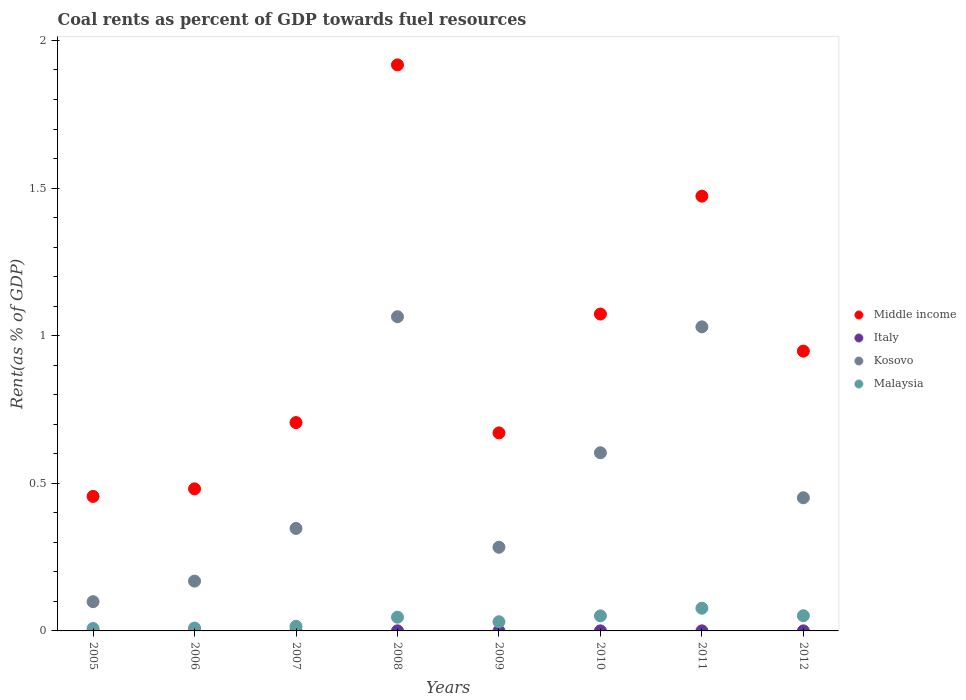What is the coal rent in Malaysia in 2011?
Provide a succinct answer. 0.08. Across all years, what is the maximum coal rent in Middle income?
Your answer should be very brief. 1.92. Across all years, what is the minimum coal rent in Italy?
Your answer should be compact. 5.16849671469394e-6. In which year was the coal rent in Italy maximum?
Provide a short and direct response. 2008. What is the total coal rent in Kosovo in the graph?
Offer a very short reply. 4.05. What is the difference between the coal rent in Italy in 2006 and that in 2010?
Make the answer very short. -0. What is the difference between the coal rent in Kosovo in 2012 and the coal rent in Italy in 2007?
Your answer should be very brief. 0.45. What is the average coal rent in Italy per year?
Offer a terse response. 0. In the year 2011, what is the difference between the coal rent in Italy and coal rent in Malaysia?
Provide a succinct answer. -0.08. In how many years, is the coal rent in Middle income greater than 0.30000000000000004 %?
Provide a short and direct response. 8. What is the ratio of the coal rent in Kosovo in 2009 to that in 2011?
Ensure brevity in your answer.  0.28. What is the difference between the highest and the second highest coal rent in Middle income?
Your answer should be compact. 0.44. What is the difference between the highest and the lowest coal rent in Kosovo?
Give a very brief answer. 0.97. Is the sum of the coal rent in Middle income in 2009 and 2011 greater than the maximum coal rent in Italy across all years?
Provide a succinct answer. Yes. Is it the case that in every year, the sum of the coal rent in Kosovo and coal rent in Middle income  is greater than the sum of coal rent in Italy and coal rent in Malaysia?
Offer a very short reply. Yes. Does the coal rent in Italy monotonically increase over the years?
Offer a terse response. No. Is the coal rent in Italy strictly greater than the coal rent in Middle income over the years?
Ensure brevity in your answer.  No. How many dotlines are there?
Provide a short and direct response. 4. What is the difference between two consecutive major ticks on the Y-axis?
Provide a short and direct response. 0.5. Where does the legend appear in the graph?
Provide a succinct answer. Center right. What is the title of the graph?
Your response must be concise. Coal rents as percent of GDP towards fuel resources. What is the label or title of the X-axis?
Offer a very short reply. Years. What is the label or title of the Y-axis?
Your answer should be very brief. Rent(as % of GDP). What is the Rent(as % of GDP) in Middle income in 2005?
Your answer should be very brief. 0.46. What is the Rent(as % of GDP) of Italy in 2005?
Provide a short and direct response. 1.52938665315344e-5. What is the Rent(as % of GDP) of Kosovo in 2005?
Keep it short and to the point. 0.1. What is the Rent(as % of GDP) of Malaysia in 2005?
Offer a terse response. 0.01. What is the Rent(as % of GDP) of Middle income in 2006?
Offer a very short reply. 0.48. What is the Rent(as % of GDP) in Italy in 2006?
Your response must be concise. 5.16849671469394e-6. What is the Rent(as % of GDP) in Kosovo in 2006?
Your response must be concise. 0.17. What is the Rent(as % of GDP) of Malaysia in 2006?
Make the answer very short. 0.01. What is the Rent(as % of GDP) of Middle income in 2007?
Keep it short and to the point. 0.71. What is the Rent(as % of GDP) of Italy in 2007?
Ensure brevity in your answer.  0. What is the Rent(as % of GDP) in Kosovo in 2007?
Your answer should be compact. 0.35. What is the Rent(as % of GDP) of Malaysia in 2007?
Make the answer very short. 0.02. What is the Rent(as % of GDP) of Middle income in 2008?
Make the answer very short. 1.92. What is the Rent(as % of GDP) of Italy in 2008?
Offer a terse response. 0. What is the Rent(as % of GDP) in Kosovo in 2008?
Offer a very short reply. 1.06. What is the Rent(as % of GDP) of Malaysia in 2008?
Ensure brevity in your answer.  0.05. What is the Rent(as % of GDP) of Middle income in 2009?
Provide a short and direct response. 0.67. What is the Rent(as % of GDP) of Italy in 2009?
Keep it short and to the point. 5.380155600468061e-5. What is the Rent(as % of GDP) of Kosovo in 2009?
Your response must be concise. 0.28. What is the Rent(as % of GDP) of Malaysia in 2009?
Your answer should be compact. 0.03. What is the Rent(as % of GDP) of Middle income in 2010?
Your answer should be compact. 1.07. What is the Rent(as % of GDP) in Italy in 2010?
Ensure brevity in your answer.  0. What is the Rent(as % of GDP) in Kosovo in 2010?
Offer a terse response. 0.6. What is the Rent(as % of GDP) of Malaysia in 2010?
Keep it short and to the point. 0.05. What is the Rent(as % of GDP) in Middle income in 2011?
Your answer should be compact. 1.47. What is the Rent(as % of GDP) in Italy in 2011?
Keep it short and to the point. 0. What is the Rent(as % of GDP) in Kosovo in 2011?
Give a very brief answer. 1.03. What is the Rent(as % of GDP) of Malaysia in 2011?
Give a very brief answer. 0.08. What is the Rent(as % of GDP) in Middle income in 2012?
Offer a very short reply. 0.95. What is the Rent(as % of GDP) of Italy in 2012?
Offer a terse response. 0. What is the Rent(as % of GDP) in Kosovo in 2012?
Provide a short and direct response. 0.45. What is the Rent(as % of GDP) of Malaysia in 2012?
Your answer should be compact. 0.05. Across all years, what is the maximum Rent(as % of GDP) in Middle income?
Provide a short and direct response. 1.92. Across all years, what is the maximum Rent(as % of GDP) of Italy?
Offer a very short reply. 0. Across all years, what is the maximum Rent(as % of GDP) of Kosovo?
Provide a succinct answer. 1.06. Across all years, what is the maximum Rent(as % of GDP) in Malaysia?
Ensure brevity in your answer.  0.08. Across all years, what is the minimum Rent(as % of GDP) of Middle income?
Make the answer very short. 0.46. Across all years, what is the minimum Rent(as % of GDP) in Italy?
Offer a very short reply. 5.16849671469394e-6. Across all years, what is the minimum Rent(as % of GDP) in Kosovo?
Your answer should be compact. 0.1. Across all years, what is the minimum Rent(as % of GDP) in Malaysia?
Your answer should be compact. 0.01. What is the total Rent(as % of GDP) of Middle income in the graph?
Make the answer very short. 7.72. What is the total Rent(as % of GDP) of Italy in the graph?
Keep it short and to the point. 0. What is the total Rent(as % of GDP) of Kosovo in the graph?
Ensure brevity in your answer.  4.05. What is the total Rent(as % of GDP) of Malaysia in the graph?
Offer a terse response. 0.29. What is the difference between the Rent(as % of GDP) of Middle income in 2005 and that in 2006?
Your answer should be compact. -0.03. What is the difference between the Rent(as % of GDP) in Kosovo in 2005 and that in 2006?
Offer a very short reply. -0.07. What is the difference between the Rent(as % of GDP) of Malaysia in 2005 and that in 2006?
Your answer should be very brief. -0. What is the difference between the Rent(as % of GDP) in Middle income in 2005 and that in 2007?
Your answer should be compact. -0.25. What is the difference between the Rent(as % of GDP) in Italy in 2005 and that in 2007?
Your answer should be compact. -0. What is the difference between the Rent(as % of GDP) of Kosovo in 2005 and that in 2007?
Ensure brevity in your answer.  -0.25. What is the difference between the Rent(as % of GDP) of Malaysia in 2005 and that in 2007?
Give a very brief answer. -0.01. What is the difference between the Rent(as % of GDP) in Middle income in 2005 and that in 2008?
Your answer should be very brief. -1.46. What is the difference between the Rent(as % of GDP) in Italy in 2005 and that in 2008?
Make the answer very short. -0. What is the difference between the Rent(as % of GDP) in Kosovo in 2005 and that in 2008?
Provide a short and direct response. -0.97. What is the difference between the Rent(as % of GDP) in Malaysia in 2005 and that in 2008?
Provide a short and direct response. -0.04. What is the difference between the Rent(as % of GDP) in Middle income in 2005 and that in 2009?
Your response must be concise. -0.22. What is the difference between the Rent(as % of GDP) of Italy in 2005 and that in 2009?
Ensure brevity in your answer.  -0. What is the difference between the Rent(as % of GDP) in Kosovo in 2005 and that in 2009?
Offer a very short reply. -0.18. What is the difference between the Rent(as % of GDP) in Malaysia in 2005 and that in 2009?
Offer a very short reply. -0.02. What is the difference between the Rent(as % of GDP) of Middle income in 2005 and that in 2010?
Offer a terse response. -0.62. What is the difference between the Rent(as % of GDP) in Italy in 2005 and that in 2010?
Your answer should be compact. -0. What is the difference between the Rent(as % of GDP) in Kosovo in 2005 and that in 2010?
Your response must be concise. -0.5. What is the difference between the Rent(as % of GDP) of Malaysia in 2005 and that in 2010?
Make the answer very short. -0.04. What is the difference between the Rent(as % of GDP) of Middle income in 2005 and that in 2011?
Your response must be concise. -1.02. What is the difference between the Rent(as % of GDP) in Italy in 2005 and that in 2011?
Keep it short and to the point. -0. What is the difference between the Rent(as % of GDP) in Kosovo in 2005 and that in 2011?
Ensure brevity in your answer.  -0.93. What is the difference between the Rent(as % of GDP) in Malaysia in 2005 and that in 2011?
Your response must be concise. -0.07. What is the difference between the Rent(as % of GDP) of Middle income in 2005 and that in 2012?
Make the answer very short. -0.49. What is the difference between the Rent(as % of GDP) in Italy in 2005 and that in 2012?
Offer a terse response. -0. What is the difference between the Rent(as % of GDP) of Kosovo in 2005 and that in 2012?
Give a very brief answer. -0.35. What is the difference between the Rent(as % of GDP) of Malaysia in 2005 and that in 2012?
Ensure brevity in your answer.  -0.04. What is the difference between the Rent(as % of GDP) of Middle income in 2006 and that in 2007?
Offer a very short reply. -0.22. What is the difference between the Rent(as % of GDP) of Italy in 2006 and that in 2007?
Your answer should be compact. -0. What is the difference between the Rent(as % of GDP) of Kosovo in 2006 and that in 2007?
Offer a very short reply. -0.18. What is the difference between the Rent(as % of GDP) of Malaysia in 2006 and that in 2007?
Provide a succinct answer. -0.01. What is the difference between the Rent(as % of GDP) in Middle income in 2006 and that in 2008?
Your answer should be very brief. -1.44. What is the difference between the Rent(as % of GDP) of Italy in 2006 and that in 2008?
Give a very brief answer. -0. What is the difference between the Rent(as % of GDP) in Kosovo in 2006 and that in 2008?
Offer a terse response. -0.9. What is the difference between the Rent(as % of GDP) of Malaysia in 2006 and that in 2008?
Provide a short and direct response. -0.04. What is the difference between the Rent(as % of GDP) in Middle income in 2006 and that in 2009?
Offer a terse response. -0.19. What is the difference between the Rent(as % of GDP) in Italy in 2006 and that in 2009?
Your answer should be compact. -0. What is the difference between the Rent(as % of GDP) in Kosovo in 2006 and that in 2009?
Your response must be concise. -0.11. What is the difference between the Rent(as % of GDP) in Malaysia in 2006 and that in 2009?
Your answer should be compact. -0.02. What is the difference between the Rent(as % of GDP) in Middle income in 2006 and that in 2010?
Offer a very short reply. -0.59. What is the difference between the Rent(as % of GDP) in Italy in 2006 and that in 2010?
Your answer should be compact. -0. What is the difference between the Rent(as % of GDP) of Kosovo in 2006 and that in 2010?
Your answer should be very brief. -0.43. What is the difference between the Rent(as % of GDP) in Malaysia in 2006 and that in 2010?
Give a very brief answer. -0.04. What is the difference between the Rent(as % of GDP) of Middle income in 2006 and that in 2011?
Provide a short and direct response. -0.99. What is the difference between the Rent(as % of GDP) in Italy in 2006 and that in 2011?
Your answer should be compact. -0. What is the difference between the Rent(as % of GDP) in Kosovo in 2006 and that in 2011?
Offer a terse response. -0.86. What is the difference between the Rent(as % of GDP) of Malaysia in 2006 and that in 2011?
Offer a very short reply. -0.07. What is the difference between the Rent(as % of GDP) in Middle income in 2006 and that in 2012?
Ensure brevity in your answer.  -0.47. What is the difference between the Rent(as % of GDP) in Italy in 2006 and that in 2012?
Offer a very short reply. -0. What is the difference between the Rent(as % of GDP) in Kosovo in 2006 and that in 2012?
Give a very brief answer. -0.28. What is the difference between the Rent(as % of GDP) of Malaysia in 2006 and that in 2012?
Give a very brief answer. -0.04. What is the difference between the Rent(as % of GDP) of Middle income in 2007 and that in 2008?
Provide a short and direct response. -1.21. What is the difference between the Rent(as % of GDP) in Italy in 2007 and that in 2008?
Provide a succinct answer. -0. What is the difference between the Rent(as % of GDP) of Kosovo in 2007 and that in 2008?
Offer a terse response. -0.72. What is the difference between the Rent(as % of GDP) in Malaysia in 2007 and that in 2008?
Your response must be concise. -0.03. What is the difference between the Rent(as % of GDP) in Middle income in 2007 and that in 2009?
Your answer should be compact. 0.04. What is the difference between the Rent(as % of GDP) in Italy in 2007 and that in 2009?
Ensure brevity in your answer.  0. What is the difference between the Rent(as % of GDP) of Kosovo in 2007 and that in 2009?
Your response must be concise. 0.06. What is the difference between the Rent(as % of GDP) in Malaysia in 2007 and that in 2009?
Make the answer very short. -0.02. What is the difference between the Rent(as % of GDP) in Middle income in 2007 and that in 2010?
Your response must be concise. -0.37. What is the difference between the Rent(as % of GDP) of Italy in 2007 and that in 2010?
Your response must be concise. -0. What is the difference between the Rent(as % of GDP) of Kosovo in 2007 and that in 2010?
Your answer should be very brief. -0.26. What is the difference between the Rent(as % of GDP) of Malaysia in 2007 and that in 2010?
Make the answer very short. -0.04. What is the difference between the Rent(as % of GDP) of Middle income in 2007 and that in 2011?
Offer a very short reply. -0.77. What is the difference between the Rent(as % of GDP) of Italy in 2007 and that in 2011?
Provide a short and direct response. -0. What is the difference between the Rent(as % of GDP) of Kosovo in 2007 and that in 2011?
Provide a short and direct response. -0.68. What is the difference between the Rent(as % of GDP) in Malaysia in 2007 and that in 2011?
Ensure brevity in your answer.  -0.06. What is the difference between the Rent(as % of GDP) of Middle income in 2007 and that in 2012?
Your answer should be very brief. -0.24. What is the difference between the Rent(as % of GDP) in Kosovo in 2007 and that in 2012?
Provide a short and direct response. -0.1. What is the difference between the Rent(as % of GDP) in Malaysia in 2007 and that in 2012?
Offer a terse response. -0.04. What is the difference between the Rent(as % of GDP) in Middle income in 2008 and that in 2009?
Make the answer very short. 1.25. What is the difference between the Rent(as % of GDP) of Italy in 2008 and that in 2009?
Make the answer very short. 0. What is the difference between the Rent(as % of GDP) of Kosovo in 2008 and that in 2009?
Provide a short and direct response. 0.78. What is the difference between the Rent(as % of GDP) of Malaysia in 2008 and that in 2009?
Your response must be concise. 0.02. What is the difference between the Rent(as % of GDP) of Middle income in 2008 and that in 2010?
Offer a very short reply. 0.84. What is the difference between the Rent(as % of GDP) of Italy in 2008 and that in 2010?
Keep it short and to the point. 0. What is the difference between the Rent(as % of GDP) in Kosovo in 2008 and that in 2010?
Your answer should be very brief. 0.46. What is the difference between the Rent(as % of GDP) of Malaysia in 2008 and that in 2010?
Provide a short and direct response. -0. What is the difference between the Rent(as % of GDP) in Middle income in 2008 and that in 2011?
Give a very brief answer. 0.44. What is the difference between the Rent(as % of GDP) of Italy in 2008 and that in 2011?
Make the answer very short. 0. What is the difference between the Rent(as % of GDP) in Kosovo in 2008 and that in 2011?
Your response must be concise. 0.03. What is the difference between the Rent(as % of GDP) in Malaysia in 2008 and that in 2011?
Keep it short and to the point. -0.03. What is the difference between the Rent(as % of GDP) of Middle income in 2008 and that in 2012?
Keep it short and to the point. 0.97. What is the difference between the Rent(as % of GDP) of Kosovo in 2008 and that in 2012?
Keep it short and to the point. 0.61. What is the difference between the Rent(as % of GDP) in Malaysia in 2008 and that in 2012?
Your response must be concise. -0.01. What is the difference between the Rent(as % of GDP) in Middle income in 2009 and that in 2010?
Give a very brief answer. -0.4. What is the difference between the Rent(as % of GDP) of Italy in 2009 and that in 2010?
Offer a very short reply. -0. What is the difference between the Rent(as % of GDP) of Kosovo in 2009 and that in 2010?
Provide a succinct answer. -0.32. What is the difference between the Rent(as % of GDP) of Malaysia in 2009 and that in 2010?
Offer a very short reply. -0.02. What is the difference between the Rent(as % of GDP) in Middle income in 2009 and that in 2011?
Give a very brief answer. -0.8. What is the difference between the Rent(as % of GDP) in Italy in 2009 and that in 2011?
Make the answer very short. -0. What is the difference between the Rent(as % of GDP) of Kosovo in 2009 and that in 2011?
Ensure brevity in your answer.  -0.75. What is the difference between the Rent(as % of GDP) of Malaysia in 2009 and that in 2011?
Give a very brief answer. -0.05. What is the difference between the Rent(as % of GDP) of Middle income in 2009 and that in 2012?
Offer a terse response. -0.28. What is the difference between the Rent(as % of GDP) in Italy in 2009 and that in 2012?
Provide a succinct answer. -0. What is the difference between the Rent(as % of GDP) of Kosovo in 2009 and that in 2012?
Offer a terse response. -0.17. What is the difference between the Rent(as % of GDP) in Malaysia in 2009 and that in 2012?
Give a very brief answer. -0.02. What is the difference between the Rent(as % of GDP) in Middle income in 2010 and that in 2011?
Your response must be concise. -0.4. What is the difference between the Rent(as % of GDP) of Italy in 2010 and that in 2011?
Your answer should be compact. -0. What is the difference between the Rent(as % of GDP) of Kosovo in 2010 and that in 2011?
Offer a very short reply. -0.43. What is the difference between the Rent(as % of GDP) in Malaysia in 2010 and that in 2011?
Give a very brief answer. -0.03. What is the difference between the Rent(as % of GDP) in Middle income in 2010 and that in 2012?
Offer a very short reply. 0.13. What is the difference between the Rent(as % of GDP) of Kosovo in 2010 and that in 2012?
Your answer should be compact. 0.15. What is the difference between the Rent(as % of GDP) of Malaysia in 2010 and that in 2012?
Provide a short and direct response. -0. What is the difference between the Rent(as % of GDP) in Middle income in 2011 and that in 2012?
Give a very brief answer. 0.52. What is the difference between the Rent(as % of GDP) in Italy in 2011 and that in 2012?
Provide a succinct answer. 0. What is the difference between the Rent(as % of GDP) of Kosovo in 2011 and that in 2012?
Offer a terse response. 0.58. What is the difference between the Rent(as % of GDP) in Malaysia in 2011 and that in 2012?
Provide a short and direct response. 0.03. What is the difference between the Rent(as % of GDP) of Middle income in 2005 and the Rent(as % of GDP) of Italy in 2006?
Your answer should be very brief. 0.46. What is the difference between the Rent(as % of GDP) of Middle income in 2005 and the Rent(as % of GDP) of Kosovo in 2006?
Provide a short and direct response. 0.29. What is the difference between the Rent(as % of GDP) in Middle income in 2005 and the Rent(as % of GDP) in Malaysia in 2006?
Your response must be concise. 0.45. What is the difference between the Rent(as % of GDP) in Italy in 2005 and the Rent(as % of GDP) in Kosovo in 2006?
Ensure brevity in your answer.  -0.17. What is the difference between the Rent(as % of GDP) in Italy in 2005 and the Rent(as % of GDP) in Malaysia in 2006?
Keep it short and to the point. -0.01. What is the difference between the Rent(as % of GDP) of Kosovo in 2005 and the Rent(as % of GDP) of Malaysia in 2006?
Your answer should be very brief. 0.09. What is the difference between the Rent(as % of GDP) in Middle income in 2005 and the Rent(as % of GDP) in Italy in 2007?
Give a very brief answer. 0.46. What is the difference between the Rent(as % of GDP) in Middle income in 2005 and the Rent(as % of GDP) in Kosovo in 2007?
Offer a terse response. 0.11. What is the difference between the Rent(as % of GDP) in Middle income in 2005 and the Rent(as % of GDP) in Malaysia in 2007?
Provide a succinct answer. 0.44. What is the difference between the Rent(as % of GDP) in Italy in 2005 and the Rent(as % of GDP) in Kosovo in 2007?
Offer a very short reply. -0.35. What is the difference between the Rent(as % of GDP) of Italy in 2005 and the Rent(as % of GDP) of Malaysia in 2007?
Offer a very short reply. -0.02. What is the difference between the Rent(as % of GDP) in Kosovo in 2005 and the Rent(as % of GDP) in Malaysia in 2007?
Provide a succinct answer. 0.08. What is the difference between the Rent(as % of GDP) in Middle income in 2005 and the Rent(as % of GDP) in Italy in 2008?
Offer a terse response. 0.46. What is the difference between the Rent(as % of GDP) in Middle income in 2005 and the Rent(as % of GDP) in Kosovo in 2008?
Your answer should be compact. -0.61. What is the difference between the Rent(as % of GDP) of Middle income in 2005 and the Rent(as % of GDP) of Malaysia in 2008?
Offer a very short reply. 0.41. What is the difference between the Rent(as % of GDP) in Italy in 2005 and the Rent(as % of GDP) in Kosovo in 2008?
Provide a short and direct response. -1.06. What is the difference between the Rent(as % of GDP) of Italy in 2005 and the Rent(as % of GDP) of Malaysia in 2008?
Your response must be concise. -0.05. What is the difference between the Rent(as % of GDP) of Kosovo in 2005 and the Rent(as % of GDP) of Malaysia in 2008?
Provide a short and direct response. 0.05. What is the difference between the Rent(as % of GDP) of Middle income in 2005 and the Rent(as % of GDP) of Italy in 2009?
Offer a terse response. 0.46. What is the difference between the Rent(as % of GDP) of Middle income in 2005 and the Rent(as % of GDP) of Kosovo in 2009?
Ensure brevity in your answer.  0.17. What is the difference between the Rent(as % of GDP) of Middle income in 2005 and the Rent(as % of GDP) of Malaysia in 2009?
Offer a very short reply. 0.42. What is the difference between the Rent(as % of GDP) in Italy in 2005 and the Rent(as % of GDP) in Kosovo in 2009?
Ensure brevity in your answer.  -0.28. What is the difference between the Rent(as % of GDP) in Italy in 2005 and the Rent(as % of GDP) in Malaysia in 2009?
Keep it short and to the point. -0.03. What is the difference between the Rent(as % of GDP) of Kosovo in 2005 and the Rent(as % of GDP) of Malaysia in 2009?
Your answer should be compact. 0.07. What is the difference between the Rent(as % of GDP) in Middle income in 2005 and the Rent(as % of GDP) in Italy in 2010?
Offer a very short reply. 0.46. What is the difference between the Rent(as % of GDP) of Middle income in 2005 and the Rent(as % of GDP) of Kosovo in 2010?
Offer a terse response. -0.15. What is the difference between the Rent(as % of GDP) in Middle income in 2005 and the Rent(as % of GDP) in Malaysia in 2010?
Your response must be concise. 0.4. What is the difference between the Rent(as % of GDP) of Italy in 2005 and the Rent(as % of GDP) of Kosovo in 2010?
Provide a succinct answer. -0.6. What is the difference between the Rent(as % of GDP) in Italy in 2005 and the Rent(as % of GDP) in Malaysia in 2010?
Offer a very short reply. -0.05. What is the difference between the Rent(as % of GDP) in Kosovo in 2005 and the Rent(as % of GDP) in Malaysia in 2010?
Ensure brevity in your answer.  0.05. What is the difference between the Rent(as % of GDP) of Middle income in 2005 and the Rent(as % of GDP) of Italy in 2011?
Provide a succinct answer. 0.46. What is the difference between the Rent(as % of GDP) in Middle income in 2005 and the Rent(as % of GDP) in Kosovo in 2011?
Make the answer very short. -0.57. What is the difference between the Rent(as % of GDP) in Middle income in 2005 and the Rent(as % of GDP) in Malaysia in 2011?
Make the answer very short. 0.38. What is the difference between the Rent(as % of GDP) in Italy in 2005 and the Rent(as % of GDP) in Kosovo in 2011?
Your answer should be compact. -1.03. What is the difference between the Rent(as % of GDP) of Italy in 2005 and the Rent(as % of GDP) of Malaysia in 2011?
Your response must be concise. -0.08. What is the difference between the Rent(as % of GDP) in Kosovo in 2005 and the Rent(as % of GDP) in Malaysia in 2011?
Provide a short and direct response. 0.02. What is the difference between the Rent(as % of GDP) of Middle income in 2005 and the Rent(as % of GDP) of Italy in 2012?
Your answer should be compact. 0.46. What is the difference between the Rent(as % of GDP) in Middle income in 2005 and the Rent(as % of GDP) in Kosovo in 2012?
Provide a succinct answer. 0. What is the difference between the Rent(as % of GDP) in Middle income in 2005 and the Rent(as % of GDP) in Malaysia in 2012?
Your answer should be compact. 0.4. What is the difference between the Rent(as % of GDP) of Italy in 2005 and the Rent(as % of GDP) of Kosovo in 2012?
Your answer should be compact. -0.45. What is the difference between the Rent(as % of GDP) of Italy in 2005 and the Rent(as % of GDP) of Malaysia in 2012?
Offer a very short reply. -0.05. What is the difference between the Rent(as % of GDP) in Kosovo in 2005 and the Rent(as % of GDP) in Malaysia in 2012?
Make the answer very short. 0.05. What is the difference between the Rent(as % of GDP) of Middle income in 2006 and the Rent(as % of GDP) of Italy in 2007?
Give a very brief answer. 0.48. What is the difference between the Rent(as % of GDP) of Middle income in 2006 and the Rent(as % of GDP) of Kosovo in 2007?
Your answer should be compact. 0.13. What is the difference between the Rent(as % of GDP) of Middle income in 2006 and the Rent(as % of GDP) of Malaysia in 2007?
Offer a terse response. 0.47. What is the difference between the Rent(as % of GDP) of Italy in 2006 and the Rent(as % of GDP) of Kosovo in 2007?
Your response must be concise. -0.35. What is the difference between the Rent(as % of GDP) of Italy in 2006 and the Rent(as % of GDP) of Malaysia in 2007?
Make the answer very short. -0.02. What is the difference between the Rent(as % of GDP) of Kosovo in 2006 and the Rent(as % of GDP) of Malaysia in 2007?
Your answer should be very brief. 0.15. What is the difference between the Rent(as % of GDP) of Middle income in 2006 and the Rent(as % of GDP) of Italy in 2008?
Offer a very short reply. 0.48. What is the difference between the Rent(as % of GDP) of Middle income in 2006 and the Rent(as % of GDP) of Kosovo in 2008?
Make the answer very short. -0.58. What is the difference between the Rent(as % of GDP) in Middle income in 2006 and the Rent(as % of GDP) in Malaysia in 2008?
Provide a short and direct response. 0.43. What is the difference between the Rent(as % of GDP) in Italy in 2006 and the Rent(as % of GDP) in Kosovo in 2008?
Give a very brief answer. -1.06. What is the difference between the Rent(as % of GDP) of Italy in 2006 and the Rent(as % of GDP) of Malaysia in 2008?
Your response must be concise. -0.05. What is the difference between the Rent(as % of GDP) of Kosovo in 2006 and the Rent(as % of GDP) of Malaysia in 2008?
Give a very brief answer. 0.12. What is the difference between the Rent(as % of GDP) of Middle income in 2006 and the Rent(as % of GDP) of Italy in 2009?
Your response must be concise. 0.48. What is the difference between the Rent(as % of GDP) in Middle income in 2006 and the Rent(as % of GDP) in Kosovo in 2009?
Your answer should be very brief. 0.2. What is the difference between the Rent(as % of GDP) in Middle income in 2006 and the Rent(as % of GDP) in Malaysia in 2009?
Offer a very short reply. 0.45. What is the difference between the Rent(as % of GDP) of Italy in 2006 and the Rent(as % of GDP) of Kosovo in 2009?
Ensure brevity in your answer.  -0.28. What is the difference between the Rent(as % of GDP) in Italy in 2006 and the Rent(as % of GDP) in Malaysia in 2009?
Keep it short and to the point. -0.03. What is the difference between the Rent(as % of GDP) of Kosovo in 2006 and the Rent(as % of GDP) of Malaysia in 2009?
Give a very brief answer. 0.14. What is the difference between the Rent(as % of GDP) of Middle income in 2006 and the Rent(as % of GDP) of Italy in 2010?
Make the answer very short. 0.48. What is the difference between the Rent(as % of GDP) in Middle income in 2006 and the Rent(as % of GDP) in Kosovo in 2010?
Make the answer very short. -0.12. What is the difference between the Rent(as % of GDP) in Middle income in 2006 and the Rent(as % of GDP) in Malaysia in 2010?
Your response must be concise. 0.43. What is the difference between the Rent(as % of GDP) of Italy in 2006 and the Rent(as % of GDP) of Kosovo in 2010?
Your answer should be compact. -0.6. What is the difference between the Rent(as % of GDP) of Italy in 2006 and the Rent(as % of GDP) of Malaysia in 2010?
Keep it short and to the point. -0.05. What is the difference between the Rent(as % of GDP) in Kosovo in 2006 and the Rent(as % of GDP) in Malaysia in 2010?
Give a very brief answer. 0.12. What is the difference between the Rent(as % of GDP) of Middle income in 2006 and the Rent(as % of GDP) of Italy in 2011?
Ensure brevity in your answer.  0.48. What is the difference between the Rent(as % of GDP) in Middle income in 2006 and the Rent(as % of GDP) in Kosovo in 2011?
Offer a very short reply. -0.55. What is the difference between the Rent(as % of GDP) of Middle income in 2006 and the Rent(as % of GDP) of Malaysia in 2011?
Offer a very short reply. 0.4. What is the difference between the Rent(as % of GDP) in Italy in 2006 and the Rent(as % of GDP) in Kosovo in 2011?
Provide a short and direct response. -1.03. What is the difference between the Rent(as % of GDP) in Italy in 2006 and the Rent(as % of GDP) in Malaysia in 2011?
Ensure brevity in your answer.  -0.08. What is the difference between the Rent(as % of GDP) of Kosovo in 2006 and the Rent(as % of GDP) of Malaysia in 2011?
Give a very brief answer. 0.09. What is the difference between the Rent(as % of GDP) in Middle income in 2006 and the Rent(as % of GDP) in Italy in 2012?
Make the answer very short. 0.48. What is the difference between the Rent(as % of GDP) of Middle income in 2006 and the Rent(as % of GDP) of Kosovo in 2012?
Make the answer very short. 0.03. What is the difference between the Rent(as % of GDP) in Middle income in 2006 and the Rent(as % of GDP) in Malaysia in 2012?
Offer a very short reply. 0.43. What is the difference between the Rent(as % of GDP) in Italy in 2006 and the Rent(as % of GDP) in Kosovo in 2012?
Your answer should be very brief. -0.45. What is the difference between the Rent(as % of GDP) in Italy in 2006 and the Rent(as % of GDP) in Malaysia in 2012?
Your response must be concise. -0.05. What is the difference between the Rent(as % of GDP) of Kosovo in 2006 and the Rent(as % of GDP) of Malaysia in 2012?
Offer a terse response. 0.12. What is the difference between the Rent(as % of GDP) of Middle income in 2007 and the Rent(as % of GDP) of Italy in 2008?
Make the answer very short. 0.71. What is the difference between the Rent(as % of GDP) in Middle income in 2007 and the Rent(as % of GDP) in Kosovo in 2008?
Make the answer very short. -0.36. What is the difference between the Rent(as % of GDP) of Middle income in 2007 and the Rent(as % of GDP) of Malaysia in 2008?
Keep it short and to the point. 0.66. What is the difference between the Rent(as % of GDP) of Italy in 2007 and the Rent(as % of GDP) of Kosovo in 2008?
Your answer should be very brief. -1.06. What is the difference between the Rent(as % of GDP) in Italy in 2007 and the Rent(as % of GDP) in Malaysia in 2008?
Make the answer very short. -0.05. What is the difference between the Rent(as % of GDP) in Kosovo in 2007 and the Rent(as % of GDP) in Malaysia in 2008?
Provide a short and direct response. 0.3. What is the difference between the Rent(as % of GDP) in Middle income in 2007 and the Rent(as % of GDP) in Italy in 2009?
Keep it short and to the point. 0.71. What is the difference between the Rent(as % of GDP) in Middle income in 2007 and the Rent(as % of GDP) in Kosovo in 2009?
Offer a very short reply. 0.42. What is the difference between the Rent(as % of GDP) of Middle income in 2007 and the Rent(as % of GDP) of Malaysia in 2009?
Give a very brief answer. 0.67. What is the difference between the Rent(as % of GDP) in Italy in 2007 and the Rent(as % of GDP) in Kosovo in 2009?
Ensure brevity in your answer.  -0.28. What is the difference between the Rent(as % of GDP) of Italy in 2007 and the Rent(as % of GDP) of Malaysia in 2009?
Your answer should be compact. -0.03. What is the difference between the Rent(as % of GDP) of Kosovo in 2007 and the Rent(as % of GDP) of Malaysia in 2009?
Keep it short and to the point. 0.32. What is the difference between the Rent(as % of GDP) in Middle income in 2007 and the Rent(as % of GDP) in Italy in 2010?
Offer a terse response. 0.71. What is the difference between the Rent(as % of GDP) of Middle income in 2007 and the Rent(as % of GDP) of Kosovo in 2010?
Provide a short and direct response. 0.1. What is the difference between the Rent(as % of GDP) of Middle income in 2007 and the Rent(as % of GDP) of Malaysia in 2010?
Your answer should be compact. 0.65. What is the difference between the Rent(as % of GDP) in Italy in 2007 and the Rent(as % of GDP) in Kosovo in 2010?
Provide a succinct answer. -0.6. What is the difference between the Rent(as % of GDP) in Italy in 2007 and the Rent(as % of GDP) in Malaysia in 2010?
Provide a succinct answer. -0.05. What is the difference between the Rent(as % of GDP) in Kosovo in 2007 and the Rent(as % of GDP) in Malaysia in 2010?
Offer a terse response. 0.3. What is the difference between the Rent(as % of GDP) in Middle income in 2007 and the Rent(as % of GDP) in Italy in 2011?
Give a very brief answer. 0.71. What is the difference between the Rent(as % of GDP) of Middle income in 2007 and the Rent(as % of GDP) of Kosovo in 2011?
Provide a succinct answer. -0.32. What is the difference between the Rent(as % of GDP) of Middle income in 2007 and the Rent(as % of GDP) of Malaysia in 2011?
Keep it short and to the point. 0.63. What is the difference between the Rent(as % of GDP) of Italy in 2007 and the Rent(as % of GDP) of Kosovo in 2011?
Your answer should be compact. -1.03. What is the difference between the Rent(as % of GDP) in Italy in 2007 and the Rent(as % of GDP) in Malaysia in 2011?
Your response must be concise. -0.08. What is the difference between the Rent(as % of GDP) in Kosovo in 2007 and the Rent(as % of GDP) in Malaysia in 2011?
Provide a short and direct response. 0.27. What is the difference between the Rent(as % of GDP) in Middle income in 2007 and the Rent(as % of GDP) in Italy in 2012?
Provide a succinct answer. 0.71. What is the difference between the Rent(as % of GDP) in Middle income in 2007 and the Rent(as % of GDP) in Kosovo in 2012?
Offer a terse response. 0.25. What is the difference between the Rent(as % of GDP) in Middle income in 2007 and the Rent(as % of GDP) in Malaysia in 2012?
Offer a terse response. 0.65. What is the difference between the Rent(as % of GDP) in Italy in 2007 and the Rent(as % of GDP) in Kosovo in 2012?
Provide a short and direct response. -0.45. What is the difference between the Rent(as % of GDP) of Italy in 2007 and the Rent(as % of GDP) of Malaysia in 2012?
Your answer should be compact. -0.05. What is the difference between the Rent(as % of GDP) of Kosovo in 2007 and the Rent(as % of GDP) of Malaysia in 2012?
Make the answer very short. 0.3. What is the difference between the Rent(as % of GDP) in Middle income in 2008 and the Rent(as % of GDP) in Italy in 2009?
Offer a terse response. 1.92. What is the difference between the Rent(as % of GDP) in Middle income in 2008 and the Rent(as % of GDP) in Kosovo in 2009?
Make the answer very short. 1.63. What is the difference between the Rent(as % of GDP) of Middle income in 2008 and the Rent(as % of GDP) of Malaysia in 2009?
Offer a very short reply. 1.89. What is the difference between the Rent(as % of GDP) of Italy in 2008 and the Rent(as % of GDP) of Kosovo in 2009?
Make the answer very short. -0.28. What is the difference between the Rent(as % of GDP) in Italy in 2008 and the Rent(as % of GDP) in Malaysia in 2009?
Provide a succinct answer. -0.03. What is the difference between the Rent(as % of GDP) of Kosovo in 2008 and the Rent(as % of GDP) of Malaysia in 2009?
Provide a short and direct response. 1.03. What is the difference between the Rent(as % of GDP) of Middle income in 2008 and the Rent(as % of GDP) of Italy in 2010?
Give a very brief answer. 1.92. What is the difference between the Rent(as % of GDP) in Middle income in 2008 and the Rent(as % of GDP) in Kosovo in 2010?
Keep it short and to the point. 1.31. What is the difference between the Rent(as % of GDP) in Middle income in 2008 and the Rent(as % of GDP) in Malaysia in 2010?
Offer a very short reply. 1.87. What is the difference between the Rent(as % of GDP) in Italy in 2008 and the Rent(as % of GDP) in Kosovo in 2010?
Keep it short and to the point. -0.6. What is the difference between the Rent(as % of GDP) of Italy in 2008 and the Rent(as % of GDP) of Malaysia in 2010?
Provide a short and direct response. -0.05. What is the difference between the Rent(as % of GDP) of Kosovo in 2008 and the Rent(as % of GDP) of Malaysia in 2010?
Provide a short and direct response. 1.01. What is the difference between the Rent(as % of GDP) in Middle income in 2008 and the Rent(as % of GDP) in Italy in 2011?
Your response must be concise. 1.92. What is the difference between the Rent(as % of GDP) in Middle income in 2008 and the Rent(as % of GDP) in Kosovo in 2011?
Provide a short and direct response. 0.89. What is the difference between the Rent(as % of GDP) of Middle income in 2008 and the Rent(as % of GDP) of Malaysia in 2011?
Provide a short and direct response. 1.84. What is the difference between the Rent(as % of GDP) in Italy in 2008 and the Rent(as % of GDP) in Kosovo in 2011?
Your response must be concise. -1.03. What is the difference between the Rent(as % of GDP) of Italy in 2008 and the Rent(as % of GDP) of Malaysia in 2011?
Give a very brief answer. -0.08. What is the difference between the Rent(as % of GDP) of Kosovo in 2008 and the Rent(as % of GDP) of Malaysia in 2011?
Give a very brief answer. 0.99. What is the difference between the Rent(as % of GDP) in Middle income in 2008 and the Rent(as % of GDP) in Italy in 2012?
Provide a short and direct response. 1.92. What is the difference between the Rent(as % of GDP) in Middle income in 2008 and the Rent(as % of GDP) in Kosovo in 2012?
Make the answer very short. 1.47. What is the difference between the Rent(as % of GDP) of Middle income in 2008 and the Rent(as % of GDP) of Malaysia in 2012?
Your response must be concise. 1.87. What is the difference between the Rent(as % of GDP) of Italy in 2008 and the Rent(as % of GDP) of Kosovo in 2012?
Give a very brief answer. -0.45. What is the difference between the Rent(as % of GDP) in Italy in 2008 and the Rent(as % of GDP) in Malaysia in 2012?
Give a very brief answer. -0.05. What is the difference between the Rent(as % of GDP) in Kosovo in 2008 and the Rent(as % of GDP) in Malaysia in 2012?
Provide a succinct answer. 1.01. What is the difference between the Rent(as % of GDP) in Middle income in 2009 and the Rent(as % of GDP) in Italy in 2010?
Provide a succinct answer. 0.67. What is the difference between the Rent(as % of GDP) of Middle income in 2009 and the Rent(as % of GDP) of Kosovo in 2010?
Give a very brief answer. 0.07. What is the difference between the Rent(as % of GDP) of Middle income in 2009 and the Rent(as % of GDP) of Malaysia in 2010?
Your response must be concise. 0.62. What is the difference between the Rent(as % of GDP) in Italy in 2009 and the Rent(as % of GDP) in Kosovo in 2010?
Make the answer very short. -0.6. What is the difference between the Rent(as % of GDP) in Italy in 2009 and the Rent(as % of GDP) in Malaysia in 2010?
Offer a very short reply. -0.05. What is the difference between the Rent(as % of GDP) in Kosovo in 2009 and the Rent(as % of GDP) in Malaysia in 2010?
Your answer should be compact. 0.23. What is the difference between the Rent(as % of GDP) of Middle income in 2009 and the Rent(as % of GDP) of Italy in 2011?
Ensure brevity in your answer.  0.67. What is the difference between the Rent(as % of GDP) of Middle income in 2009 and the Rent(as % of GDP) of Kosovo in 2011?
Offer a very short reply. -0.36. What is the difference between the Rent(as % of GDP) of Middle income in 2009 and the Rent(as % of GDP) of Malaysia in 2011?
Your answer should be compact. 0.59. What is the difference between the Rent(as % of GDP) of Italy in 2009 and the Rent(as % of GDP) of Kosovo in 2011?
Provide a succinct answer. -1.03. What is the difference between the Rent(as % of GDP) of Italy in 2009 and the Rent(as % of GDP) of Malaysia in 2011?
Your answer should be very brief. -0.08. What is the difference between the Rent(as % of GDP) of Kosovo in 2009 and the Rent(as % of GDP) of Malaysia in 2011?
Ensure brevity in your answer.  0.21. What is the difference between the Rent(as % of GDP) of Middle income in 2009 and the Rent(as % of GDP) of Italy in 2012?
Your response must be concise. 0.67. What is the difference between the Rent(as % of GDP) in Middle income in 2009 and the Rent(as % of GDP) in Kosovo in 2012?
Your answer should be compact. 0.22. What is the difference between the Rent(as % of GDP) of Middle income in 2009 and the Rent(as % of GDP) of Malaysia in 2012?
Offer a very short reply. 0.62. What is the difference between the Rent(as % of GDP) of Italy in 2009 and the Rent(as % of GDP) of Kosovo in 2012?
Make the answer very short. -0.45. What is the difference between the Rent(as % of GDP) in Italy in 2009 and the Rent(as % of GDP) in Malaysia in 2012?
Make the answer very short. -0.05. What is the difference between the Rent(as % of GDP) of Kosovo in 2009 and the Rent(as % of GDP) of Malaysia in 2012?
Your answer should be very brief. 0.23. What is the difference between the Rent(as % of GDP) in Middle income in 2010 and the Rent(as % of GDP) in Italy in 2011?
Your answer should be compact. 1.07. What is the difference between the Rent(as % of GDP) of Middle income in 2010 and the Rent(as % of GDP) of Kosovo in 2011?
Provide a succinct answer. 0.04. What is the difference between the Rent(as % of GDP) of Italy in 2010 and the Rent(as % of GDP) of Kosovo in 2011?
Your response must be concise. -1.03. What is the difference between the Rent(as % of GDP) of Italy in 2010 and the Rent(as % of GDP) of Malaysia in 2011?
Keep it short and to the point. -0.08. What is the difference between the Rent(as % of GDP) of Kosovo in 2010 and the Rent(as % of GDP) of Malaysia in 2011?
Ensure brevity in your answer.  0.53. What is the difference between the Rent(as % of GDP) in Middle income in 2010 and the Rent(as % of GDP) in Italy in 2012?
Your answer should be very brief. 1.07. What is the difference between the Rent(as % of GDP) in Middle income in 2010 and the Rent(as % of GDP) in Kosovo in 2012?
Ensure brevity in your answer.  0.62. What is the difference between the Rent(as % of GDP) in Middle income in 2010 and the Rent(as % of GDP) in Malaysia in 2012?
Keep it short and to the point. 1.02. What is the difference between the Rent(as % of GDP) in Italy in 2010 and the Rent(as % of GDP) in Kosovo in 2012?
Your answer should be compact. -0.45. What is the difference between the Rent(as % of GDP) of Italy in 2010 and the Rent(as % of GDP) of Malaysia in 2012?
Your response must be concise. -0.05. What is the difference between the Rent(as % of GDP) of Kosovo in 2010 and the Rent(as % of GDP) of Malaysia in 2012?
Give a very brief answer. 0.55. What is the difference between the Rent(as % of GDP) in Middle income in 2011 and the Rent(as % of GDP) in Italy in 2012?
Make the answer very short. 1.47. What is the difference between the Rent(as % of GDP) in Middle income in 2011 and the Rent(as % of GDP) in Kosovo in 2012?
Offer a very short reply. 1.02. What is the difference between the Rent(as % of GDP) of Middle income in 2011 and the Rent(as % of GDP) of Malaysia in 2012?
Make the answer very short. 1.42. What is the difference between the Rent(as % of GDP) in Italy in 2011 and the Rent(as % of GDP) in Kosovo in 2012?
Offer a terse response. -0.45. What is the difference between the Rent(as % of GDP) in Italy in 2011 and the Rent(as % of GDP) in Malaysia in 2012?
Your answer should be compact. -0.05. What is the difference between the Rent(as % of GDP) of Kosovo in 2011 and the Rent(as % of GDP) of Malaysia in 2012?
Your answer should be very brief. 0.98. What is the average Rent(as % of GDP) in Middle income per year?
Your answer should be compact. 0.97. What is the average Rent(as % of GDP) in Italy per year?
Offer a very short reply. 0. What is the average Rent(as % of GDP) of Kosovo per year?
Provide a short and direct response. 0.51. What is the average Rent(as % of GDP) in Malaysia per year?
Keep it short and to the point. 0.04. In the year 2005, what is the difference between the Rent(as % of GDP) of Middle income and Rent(as % of GDP) of Italy?
Your answer should be compact. 0.46. In the year 2005, what is the difference between the Rent(as % of GDP) in Middle income and Rent(as % of GDP) in Kosovo?
Your response must be concise. 0.36. In the year 2005, what is the difference between the Rent(as % of GDP) of Middle income and Rent(as % of GDP) of Malaysia?
Your response must be concise. 0.45. In the year 2005, what is the difference between the Rent(as % of GDP) of Italy and Rent(as % of GDP) of Kosovo?
Make the answer very short. -0.1. In the year 2005, what is the difference between the Rent(as % of GDP) of Italy and Rent(as % of GDP) of Malaysia?
Make the answer very short. -0.01. In the year 2005, what is the difference between the Rent(as % of GDP) in Kosovo and Rent(as % of GDP) in Malaysia?
Provide a succinct answer. 0.09. In the year 2006, what is the difference between the Rent(as % of GDP) of Middle income and Rent(as % of GDP) of Italy?
Your answer should be compact. 0.48. In the year 2006, what is the difference between the Rent(as % of GDP) of Middle income and Rent(as % of GDP) of Kosovo?
Keep it short and to the point. 0.31. In the year 2006, what is the difference between the Rent(as % of GDP) of Middle income and Rent(as % of GDP) of Malaysia?
Provide a short and direct response. 0.47. In the year 2006, what is the difference between the Rent(as % of GDP) of Italy and Rent(as % of GDP) of Kosovo?
Give a very brief answer. -0.17. In the year 2006, what is the difference between the Rent(as % of GDP) of Italy and Rent(as % of GDP) of Malaysia?
Your answer should be compact. -0.01. In the year 2006, what is the difference between the Rent(as % of GDP) of Kosovo and Rent(as % of GDP) of Malaysia?
Make the answer very short. 0.16. In the year 2007, what is the difference between the Rent(as % of GDP) in Middle income and Rent(as % of GDP) in Italy?
Offer a terse response. 0.71. In the year 2007, what is the difference between the Rent(as % of GDP) of Middle income and Rent(as % of GDP) of Kosovo?
Give a very brief answer. 0.36. In the year 2007, what is the difference between the Rent(as % of GDP) in Middle income and Rent(as % of GDP) in Malaysia?
Offer a terse response. 0.69. In the year 2007, what is the difference between the Rent(as % of GDP) in Italy and Rent(as % of GDP) in Kosovo?
Ensure brevity in your answer.  -0.35. In the year 2007, what is the difference between the Rent(as % of GDP) in Italy and Rent(as % of GDP) in Malaysia?
Offer a very short reply. -0.02. In the year 2007, what is the difference between the Rent(as % of GDP) in Kosovo and Rent(as % of GDP) in Malaysia?
Provide a succinct answer. 0.33. In the year 2008, what is the difference between the Rent(as % of GDP) in Middle income and Rent(as % of GDP) in Italy?
Give a very brief answer. 1.92. In the year 2008, what is the difference between the Rent(as % of GDP) of Middle income and Rent(as % of GDP) of Kosovo?
Offer a very short reply. 0.85. In the year 2008, what is the difference between the Rent(as % of GDP) in Middle income and Rent(as % of GDP) in Malaysia?
Give a very brief answer. 1.87. In the year 2008, what is the difference between the Rent(as % of GDP) of Italy and Rent(as % of GDP) of Kosovo?
Ensure brevity in your answer.  -1.06. In the year 2008, what is the difference between the Rent(as % of GDP) of Italy and Rent(as % of GDP) of Malaysia?
Give a very brief answer. -0.05. In the year 2008, what is the difference between the Rent(as % of GDP) of Kosovo and Rent(as % of GDP) of Malaysia?
Offer a very short reply. 1.02. In the year 2009, what is the difference between the Rent(as % of GDP) in Middle income and Rent(as % of GDP) in Italy?
Offer a terse response. 0.67. In the year 2009, what is the difference between the Rent(as % of GDP) in Middle income and Rent(as % of GDP) in Kosovo?
Provide a short and direct response. 0.39. In the year 2009, what is the difference between the Rent(as % of GDP) of Middle income and Rent(as % of GDP) of Malaysia?
Your response must be concise. 0.64. In the year 2009, what is the difference between the Rent(as % of GDP) in Italy and Rent(as % of GDP) in Kosovo?
Offer a very short reply. -0.28. In the year 2009, what is the difference between the Rent(as % of GDP) in Italy and Rent(as % of GDP) in Malaysia?
Keep it short and to the point. -0.03. In the year 2009, what is the difference between the Rent(as % of GDP) of Kosovo and Rent(as % of GDP) of Malaysia?
Offer a very short reply. 0.25. In the year 2010, what is the difference between the Rent(as % of GDP) in Middle income and Rent(as % of GDP) in Italy?
Your response must be concise. 1.07. In the year 2010, what is the difference between the Rent(as % of GDP) in Middle income and Rent(as % of GDP) in Kosovo?
Your answer should be very brief. 0.47. In the year 2010, what is the difference between the Rent(as % of GDP) in Middle income and Rent(as % of GDP) in Malaysia?
Offer a very short reply. 1.02. In the year 2010, what is the difference between the Rent(as % of GDP) of Italy and Rent(as % of GDP) of Kosovo?
Provide a succinct answer. -0.6. In the year 2010, what is the difference between the Rent(as % of GDP) in Italy and Rent(as % of GDP) in Malaysia?
Provide a succinct answer. -0.05. In the year 2010, what is the difference between the Rent(as % of GDP) in Kosovo and Rent(as % of GDP) in Malaysia?
Your answer should be very brief. 0.55. In the year 2011, what is the difference between the Rent(as % of GDP) in Middle income and Rent(as % of GDP) in Italy?
Provide a short and direct response. 1.47. In the year 2011, what is the difference between the Rent(as % of GDP) of Middle income and Rent(as % of GDP) of Kosovo?
Your answer should be very brief. 0.44. In the year 2011, what is the difference between the Rent(as % of GDP) of Middle income and Rent(as % of GDP) of Malaysia?
Offer a very short reply. 1.4. In the year 2011, what is the difference between the Rent(as % of GDP) in Italy and Rent(as % of GDP) in Kosovo?
Ensure brevity in your answer.  -1.03. In the year 2011, what is the difference between the Rent(as % of GDP) of Italy and Rent(as % of GDP) of Malaysia?
Keep it short and to the point. -0.08. In the year 2011, what is the difference between the Rent(as % of GDP) of Kosovo and Rent(as % of GDP) of Malaysia?
Provide a succinct answer. 0.95. In the year 2012, what is the difference between the Rent(as % of GDP) of Middle income and Rent(as % of GDP) of Italy?
Provide a short and direct response. 0.95. In the year 2012, what is the difference between the Rent(as % of GDP) of Middle income and Rent(as % of GDP) of Kosovo?
Offer a very short reply. 0.5. In the year 2012, what is the difference between the Rent(as % of GDP) in Middle income and Rent(as % of GDP) in Malaysia?
Provide a short and direct response. 0.9. In the year 2012, what is the difference between the Rent(as % of GDP) of Italy and Rent(as % of GDP) of Kosovo?
Offer a terse response. -0.45. In the year 2012, what is the difference between the Rent(as % of GDP) in Italy and Rent(as % of GDP) in Malaysia?
Make the answer very short. -0.05. In the year 2012, what is the difference between the Rent(as % of GDP) of Kosovo and Rent(as % of GDP) of Malaysia?
Provide a short and direct response. 0.4. What is the ratio of the Rent(as % of GDP) of Middle income in 2005 to that in 2006?
Provide a succinct answer. 0.95. What is the ratio of the Rent(as % of GDP) of Italy in 2005 to that in 2006?
Offer a terse response. 2.96. What is the ratio of the Rent(as % of GDP) in Kosovo in 2005 to that in 2006?
Your answer should be compact. 0.59. What is the ratio of the Rent(as % of GDP) in Malaysia in 2005 to that in 2006?
Provide a succinct answer. 0.85. What is the ratio of the Rent(as % of GDP) of Middle income in 2005 to that in 2007?
Keep it short and to the point. 0.65. What is the ratio of the Rent(as % of GDP) of Italy in 2005 to that in 2007?
Offer a terse response. 0.14. What is the ratio of the Rent(as % of GDP) of Kosovo in 2005 to that in 2007?
Your answer should be very brief. 0.29. What is the ratio of the Rent(as % of GDP) in Malaysia in 2005 to that in 2007?
Make the answer very short. 0.53. What is the ratio of the Rent(as % of GDP) of Middle income in 2005 to that in 2008?
Offer a very short reply. 0.24. What is the ratio of the Rent(as % of GDP) of Italy in 2005 to that in 2008?
Your response must be concise. 0.04. What is the ratio of the Rent(as % of GDP) of Kosovo in 2005 to that in 2008?
Give a very brief answer. 0.09. What is the ratio of the Rent(as % of GDP) in Malaysia in 2005 to that in 2008?
Provide a succinct answer. 0.18. What is the ratio of the Rent(as % of GDP) of Middle income in 2005 to that in 2009?
Ensure brevity in your answer.  0.68. What is the ratio of the Rent(as % of GDP) in Italy in 2005 to that in 2009?
Your answer should be compact. 0.28. What is the ratio of the Rent(as % of GDP) in Kosovo in 2005 to that in 2009?
Ensure brevity in your answer.  0.35. What is the ratio of the Rent(as % of GDP) in Malaysia in 2005 to that in 2009?
Your answer should be very brief. 0.26. What is the ratio of the Rent(as % of GDP) in Middle income in 2005 to that in 2010?
Offer a terse response. 0.42. What is the ratio of the Rent(as % of GDP) in Italy in 2005 to that in 2010?
Keep it short and to the point. 0.08. What is the ratio of the Rent(as % of GDP) in Kosovo in 2005 to that in 2010?
Your answer should be very brief. 0.16. What is the ratio of the Rent(as % of GDP) of Malaysia in 2005 to that in 2010?
Offer a terse response. 0.16. What is the ratio of the Rent(as % of GDP) in Middle income in 2005 to that in 2011?
Keep it short and to the point. 0.31. What is the ratio of the Rent(as % of GDP) of Italy in 2005 to that in 2011?
Offer a very short reply. 0.06. What is the ratio of the Rent(as % of GDP) of Kosovo in 2005 to that in 2011?
Make the answer very short. 0.1. What is the ratio of the Rent(as % of GDP) in Malaysia in 2005 to that in 2011?
Your response must be concise. 0.11. What is the ratio of the Rent(as % of GDP) in Middle income in 2005 to that in 2012?
Provide a short and direct response. 0.48. What is the ratio of the Rent(as % of GDP) in Italy in 2005 to that in 2012?
Your answer should be very brief. 0.11. What is the ratio of the Rent(as % of GDP) of Kosovo in 2005 to that in 2012?
Provide a short and direct response. 0.22. What is the ratio of the Rent(as % of GDP) in Malaysia in 2005 to that in 2012?
Provide a succinct answer. 0.16. What is the ratio of the Rent(as % of GDP) in Middle income in 2006 to that in 2007?
Your answer should be compact. 0.68. What is the ratio of the Rent(as % of GDP) in Italy in 2006 to that in 2007?
Offer a very short reply. 0.05. What is the ratio of the Rent(as % of GDP) of Kosovo in 2006 to that in 2007?
Make the answer very short. 0.49. What is the ratio of the Rent(as % of GDP) in Malaysia in 2006 to that in 2007?
Your answer should be very brief. 0.62. What is the ratio of the Rent(as % of GDP) in Middle income in 2006 to that in 2008?
Make the answer very short. 0.25. What is the ratio of the Rent(as % of GDP) of Italy in 2006 to that in 2008?
Offer a terse response. 0.01. What is the ratio of the Rent(as % of GDP) in Kosovo in 2006 to that in 2008?
Your response must be concise. 0.16. What is the ratio of the Rent(as % of GDP) in Malaysia in 2006 to that in 2008?
Your response must be concise. 0.21. What is the ratio of the Rent(as % of GDP) in Middle income in 2006 to that in 2009?
Your answer should be very brief. 0.72. What is the ratio of the Rent(as % of GDP) of Italy in 2006 to that in 2009?
Your response must be concise. 0.1. What is the ratio of the Rent(as % of GDP) of Kosovo in 2006 to that in 2009?
Provide a succinct answer. 0.6. What is the ratio of the Rent(as % of GDP) in Malaysia in 2006 to that in 2009?
Offer a terse response. 0.31. What is the ratio of the Rent(as % of GDP) in Middle income in 2006 to that in 2010?
Offer a terse response. 0.45. What is the ratio of the Rent(as % of GDP) in Italy in 2006 to that in 2010?
Offer a very short reply. 0.03. What is the ratio of the Rent(as % of GDP) in Kosovo in 2006 to that in 2010?
Give a very brief answer. 0.28. What is the ratio of the Rent(as % of GDP) in Malaysia in 2006 to that in 2010?
Your answer should be very brief. 0.19. What is the ratio of the Rent(as % of GDP) in Middle income in 2006 to that in 2011?
Provide a succinct answer. 0.33. What is the ratio of the Rent(as % of GDP) in Italy in 2006 to that in 2011?
Offer a very short reply. 0.02. What is the ratio of the Rent(as % of GDP) of Kosovo in 2006 to that in 2011?
Make the answer very short. 0.16. What is the ratio of the Rent(as % of GDP) in Malaysia in 2006 to that in 2011?
Provide a short and direct response. 0.13. What is the ratio of the Rent(as % of GDP) in Middle income in 2006 to that in 2012?
Make the answer very short. 0.51. What is the ratio of the Rent(as % of GDP) of Italy in 2006 to that in 2012?
Offer a very short reply. 0.04. What is the ratio of the Rent(as % of GDP) in Kosovo in 2006 to that in 2012?
Give a very brief answer. 0.37. What is the ratio of the Rent(as % of GDP) in Malaysia in 2006 to that in 2012?
Give a very brief answer. 0.19. What is the ratio of the Rent(as % of GDP) of Middle income in 2007 to that in 2008?
Provide a short and direct response. 0.37. What is the ratio of the Rent(as % of GDP) of Italy in 2007 to that in 2008?
Your answer should be very brief. 0.32. What is the ratio of the Rent(as % of GDP) in Kosovo in 2007 to that in 2008?
Provide a succinct answer. 0.33. What is the ratio of the Rent(as % of GDP) in Malaysia in 2007 to that in 2008?
Your answer should be very brief. 0.33. What is the ratio of the Rent(as % of GDP) in Middle income in 2007 to that in 2009?
Provide a short and direct response. 1.05. What is the ratio of the Rent(as % of GDP) in Italy in 2007 to that in 2009?
Provide a succinct answer. 2.07. What is the ratio of the Rent(as % of GDP) of Kosovo in 2007 to that in 2009?
Give a very brief answer. 1.23. What is the ratio of the Rent(as % of GDP) in Malaysia in 2007 to that in 2009?
Make the answer very short. 0.5. What is the ratio of the Rent(as % of GDP) in Middle income in 2007 to that in 2010?
Offer a very short reply. 0.66. What is the ratio of the Rent(as % of GDP) in Italy in 2007 to that in 2010?
Make the answer very short. 0.6. What is the ratio of the Rent(as % of GDP) of Kosovo in 2007 to that in 2010?
Offer a very short reply. 0.58. What is the ratio of the Rent(as % of GDP) in Malaysia in 2007 to that in 2010?
Your response must be concise. 0.3. What is the ratio of the Rent(as % of GDP) in Middle income in 2007 to that in 2011?
Your answer should be very brief. 0.48. What is the ratio of the Rent(as % of GDP) in Italy in 2007 to that in 2011?
Your answer should be very brief. 0.45. What is the ratio of the Rent(as % of GDP) of Kosovo in 2007 to that in 2011?
Offer a very short reply. 0.34. What is the ratio of the Rent(as % of GDP) of Malaysia in 2007 to that in 2011?
Provide a short and direct response. 0.2. What is the ratio of the Rent(as % of GDP) of Middle income in 2007 to that in 2012?
Provide a short and direct response. 0.74. What is the ratio of the Rent(as % of GDP) of Italy in 2007 to that in 2012?
Provide a short and direct response. 0.78. What is the ratio of the Rent(as % of GDP) in Kosovo in 2007 to that in 2012?
Offer a very short reply. 0.77. What is the ratio of the Rent(as % of GDP) of Malaysia in 2007 to that in 2012?
Ensure brevity in your answer.  0.3. What is the ratio of the Rent(as % of GDP) in Middle income in 2008 to that in 2009?
Give a very brief answer. 2.86. What is the ratio of the Rent(as % of GDP) in Italy in 2008 to that in 2009?
Your answer should be compact. 6.54. What is the ratio of the Rent(as % of GDP) in Kosovo in 2008 to that in 2009?
Your answer should be compact. 3.75. What is the ratio of the Rent(as % of GDP) of Malaysia in 2008 to that in 2009?
Your answer should be compact. 1.49. What is the ratio of the Rent(as % of GDP) in Middle income in 2008 to that in 2010?
Ensure brevity in your answer.  1.79. What is the ratio of the Rent(as % of GDP) of Italy in 2008 to that in 2010?
Provide a succinct answer. 1.89. What is the ratio of the Rent(as % of GDP) in Kosovo in 2008 to that in 2010?
Provide a short and direct response. 1.76. What is the ratio of the Rent(as % of GDP) of Malaysia in 2008 to that in 2010?
Provide a short and direct response. 0.91. What is the ratio of the Rent(as % of GDP) of Middle income in 2008 to that in 2011?
Give a very brief answer. 1.3. What is the ratio of the Rent(as % of GDP) of Italy in 2008 to that in 2011?
Offer a terse response. 1.41. What is the ratio of the Rent(as % of GDP) in Malaysia in 2008 to that in 2011?
Ensure brevity in your answer.  0.6. What is the ratio of the Rent(as % of GDP) in Middle income in 2008 to that in 2012?
Make the answer very short. 2.02. What is the ratio of the Rent(as % of GDP) in Italy in 2008 to that in 2012?
Ensure brevity in your answer.  2.48. What is the ratio of the Rent(as % of GDP) of Kosovo in 2008 to that in 2012?
Keep it short and to the point. 2.36. What is the ratio of the Rent(as % of GDP) in Malaysia in 2008 to that in 2012?
Keep it short and to the point. 0.9. What is the ratio of the Rent(as % of GDP) in Middle income in 2009 to that in 2010?
Give a very brief answer. 0.62. What is the ratio of the Rent(as % of GDP) in Italy in 2009 to that in 2010?
Offer a very short reply. 0.29. What is the ratio of the Rent(as % of GDP) in Kosovo in 2009 to that in 2010?
Keep it short and to the point. 0.47. What is the ratio of the Rent(as % of GDP) of Malaysia in 2009 to that in 2010?
Your answer should be compact. 0.61. What is the ratio of the Rent(as % of GDP) in Middle income in 2009 to that in 2011?
Offer a terse response. 0.46. What is the ratio of the Rent(as % of GDP) in Italy in 2009 to that in 2011?
Your response must be concise. 0.22. What is the ratio of the Rent(as % of GDP) in Kosovo in 2009 to that in 2011?
Your answer should be compact. 0.28. What is the ratio of the Rent(as % of GDP) in Malaysia in 2009 to that in 2011?
Provide a short and direct response. 0.4. What is the ratio of the Rent(as % of GDP) in Middle income in 2009 to that in 2012?
Make the answer very short. 0.71. What is the ratio of the Rent(as % of GDP) in Italy in 2009 to that in 2012?
Offer a very short reply. 0.38. What is the ratio of the Rent(as % of GDP) of Kosovo in 2009 to that in 2012?
Provide a short and direct response. 0.63. What is the ratio of the Rent(as % of GDP) of Malaysia in 2009 to that in 2012?
Provide a short and direct response. 0.6. What is the ratio of the Rent(as % of GDP) of Middle income in 2010 to that in 2011?
Provide a short and direct response. 0.73. What is the ratio of the Rent(as % of GDP) of Italy in 2010 to that in 2011?
Your response must be concise. 0.75. What is the ratio of the Rent(as % of GDP) in Kosovo in 2010 to that in 2011?
Your response must be concise. 0.59. What is the ratio of the Rent(as % of GDP) in Malaysia in 2010 to that in 2011?
Offer a terse response. 0.66. What is the ratio of the Rent(as % of GDP) of Middle income in 2010 to that in 2012?
Keep it short and to the point. 1.13. What is the ratio of the Rent(as % of GDP) in Italy in 2010 to that in 2012?
Provide a short and direct response. 1.31. What is the ratio of the Rent(as % of GDP) in Kosovo in 2010 to that in 2012?
Your answer should be compact. 1.34. What is the ratio of the Rent(as % of GDP) in Middle income in 2011 to that in 2012?
Provide a short and direct response. 1.55. What is the ratio of the Rent(as % of GDP) in Italy in 2011 to that in 2012?
Provide a succinct answer. 1.76. What is the ratio of the Rent(as % of GDP) in Kosovo in 2011 to that in 2012?
Offer a very short reply. 2.28. What is the ratio of the Rent(as % of GDP) in Malaysia in 2011 to that in 2012?
Make the answer very short. 1.49. What is the difference between the highest and the second highest Rent(as % of GDP) in Middle income?
Provide a short and direct response. 0.44. What is the difference between the highest and the second highest Rent(as % of GDP) in Kosovo?
Offer a very short reply. 0.03. What is the difference between the highest and the second highest Rent(as % of GDP) in Malaysia?
Keep it short and to the point. 0.03. What is the difference between the highest and the lowest Rent(as % of GDP) in Middle income?
Give a very brief answer. 1.46. What is the difference between the highest and the lowest Rent(as % of GDP) in Italy?
Ensure brevity in your answer.  0. What is the difference between the highest and the lowest Rent(as % of GDP) in Kosovo?
Offer a terse response. 0.97. What is the difference between the highest and the lowest Rent(as % of GDP) in Malaysia?
Ensure brevity in your answer.  0.07. 